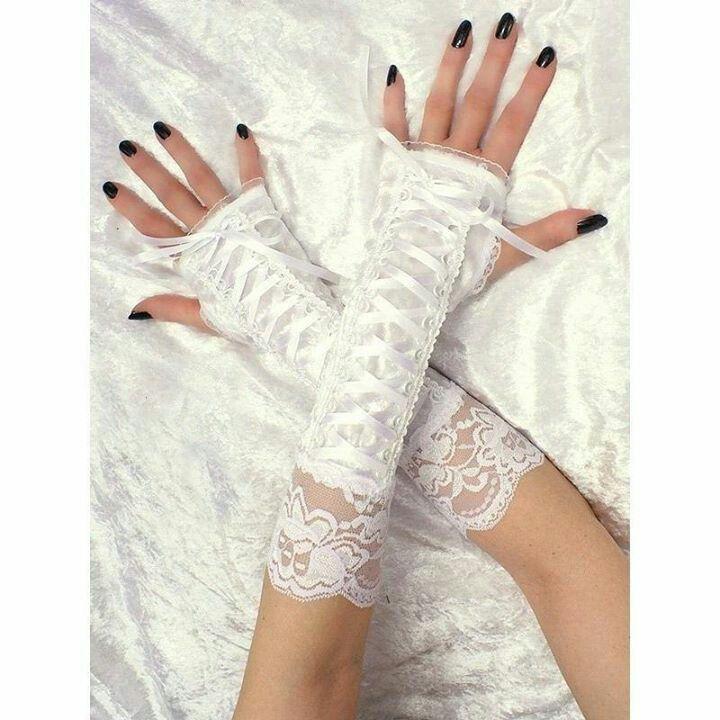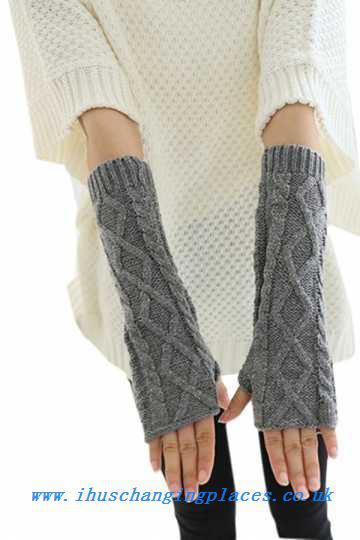The first image is the image on the left, the second image is the image on the right. Examine the images to the left and right. Is the description "A white pair of gloves is modeled on crossed hands, while a casual knit pair is modeled side by side." accurate? Answer yes or no. Yes. The first image is the image on the left, the second image is the image on the right. Given the left and right images, does the statement "Each image shows a pair of completely fingerless 'gloves' worn by a model, and the hands wearing gloves are posed fingers-up on the left, and fingers-down on the right." hold true? Answer yes or no. Yes. 